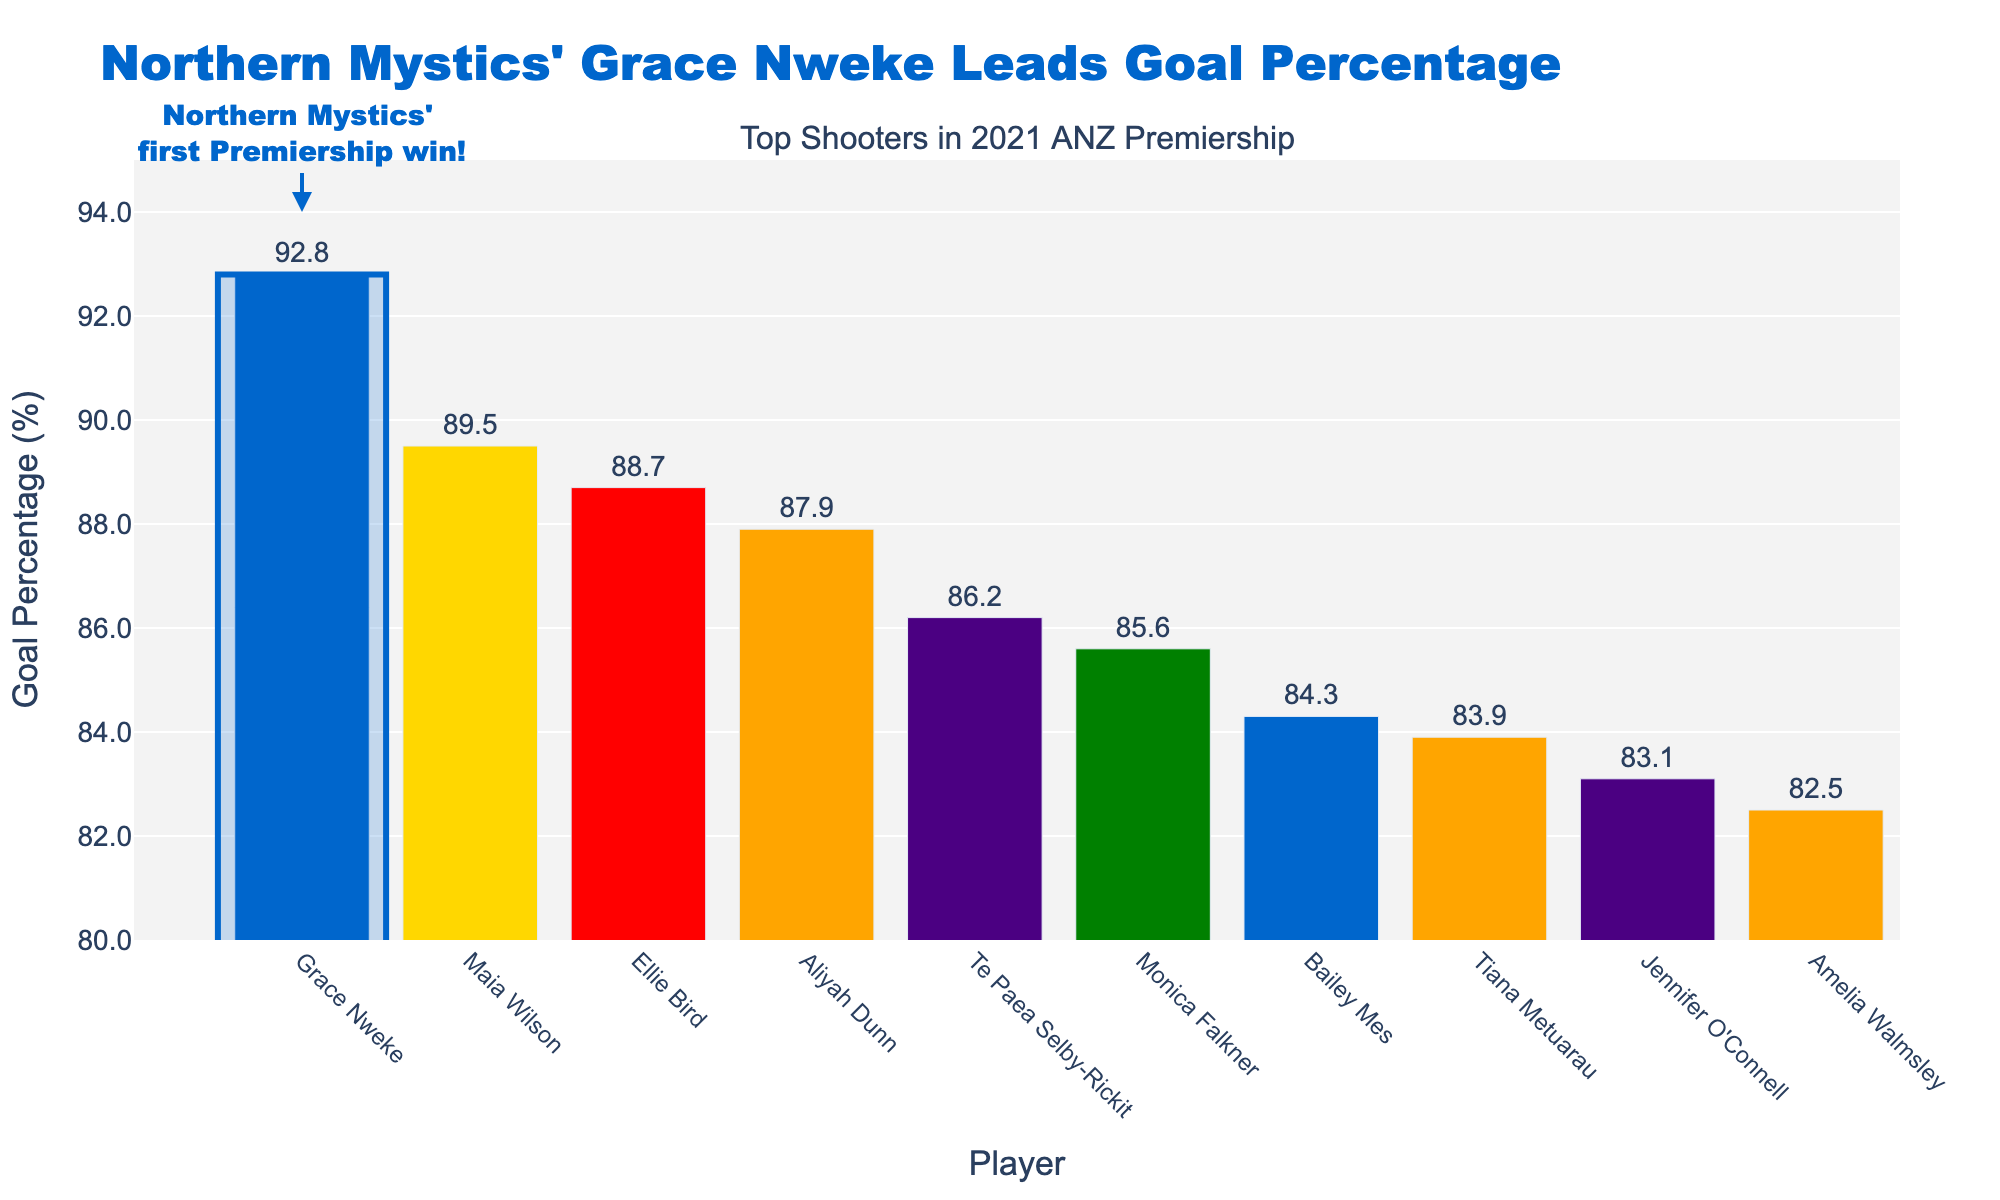Which player has the highest goal percentage? The player with the highest bar represents the highest goal percentage. Grace Nweke has the highest bar with a goal percentage of 92.8%.
Answer: Grace Nweke Which team does the player with the highest goal percentage belong to? The color of the bar associated with the highest goal percentage matches the Northern Mystics' color. The annotation also mentions Northern Mystics' first Premiership win, confirming it is Grace Nweke.
Answer: Northern Mystics How many players have a goal percentage above 90%? Visually count the bars that exceed the 90% mark on the y-axis. Only Grace Nweke’s bar is above this mark.
Answer: 1 Who is the second top scorer in terms of goal percentage? The second highest bar represents Maia Wilson with a goal percentage of 89.5%.
Answer: Maia Wilson What is the difference between the goal percentages of Grace Nweke and Bailey Mes? Subtract Bailey Mes's goal percentage from Grace Nweke's: 92.8% - 84.3% = 8.5%.
Answer: 8.5% How many players scored below 85%? Count the number of bars that are below the 85% mark on the y-axis. Three players (Tiana Metuarau, Jennifer O'Connell, and Amelia Walmsley) scored below 85%.
Answer: 3 Which team has the most players listed among the top shooters? Count the number of bars per team. Central Pulse has three players: Aliyah Dunn, Tiana Metuarau, and Amelia Walmsley.
Answer: Central Pulse What is the median goal percentage among the listed top shooters? List out the goal percentages, sort them: [92.8, 89.5, 88.7, 87.9, 86.2, 85.6, 84.3, 83.9, 83.1, 82.5]. The median value lies between 86.2 and 85.6. Thus, the median is (86.2 + 85.6) / 2 = 85.9.
Answer: 85.9 Which player has the lowest goal percentage and what is it? The shortest bar represents Amelia Walmsley with a goal percentage of 82.5%.
Answer: Amelia Walmsley, 82.5% How much higher is Grace Nweke's goal percentage compared to the average goal percentage of the top 10 shooters? Calculate the average percentage first: (92.8 + 89.5 + 88.7 + 87.9 + 86.2 + 85.6 + 84.3 + 83.9 + 83.1 + 82.5) / 10 = 86.45%. Then, find the difference: 92.8% - 86.45% = 6.35%.
Answer: 6.35% 